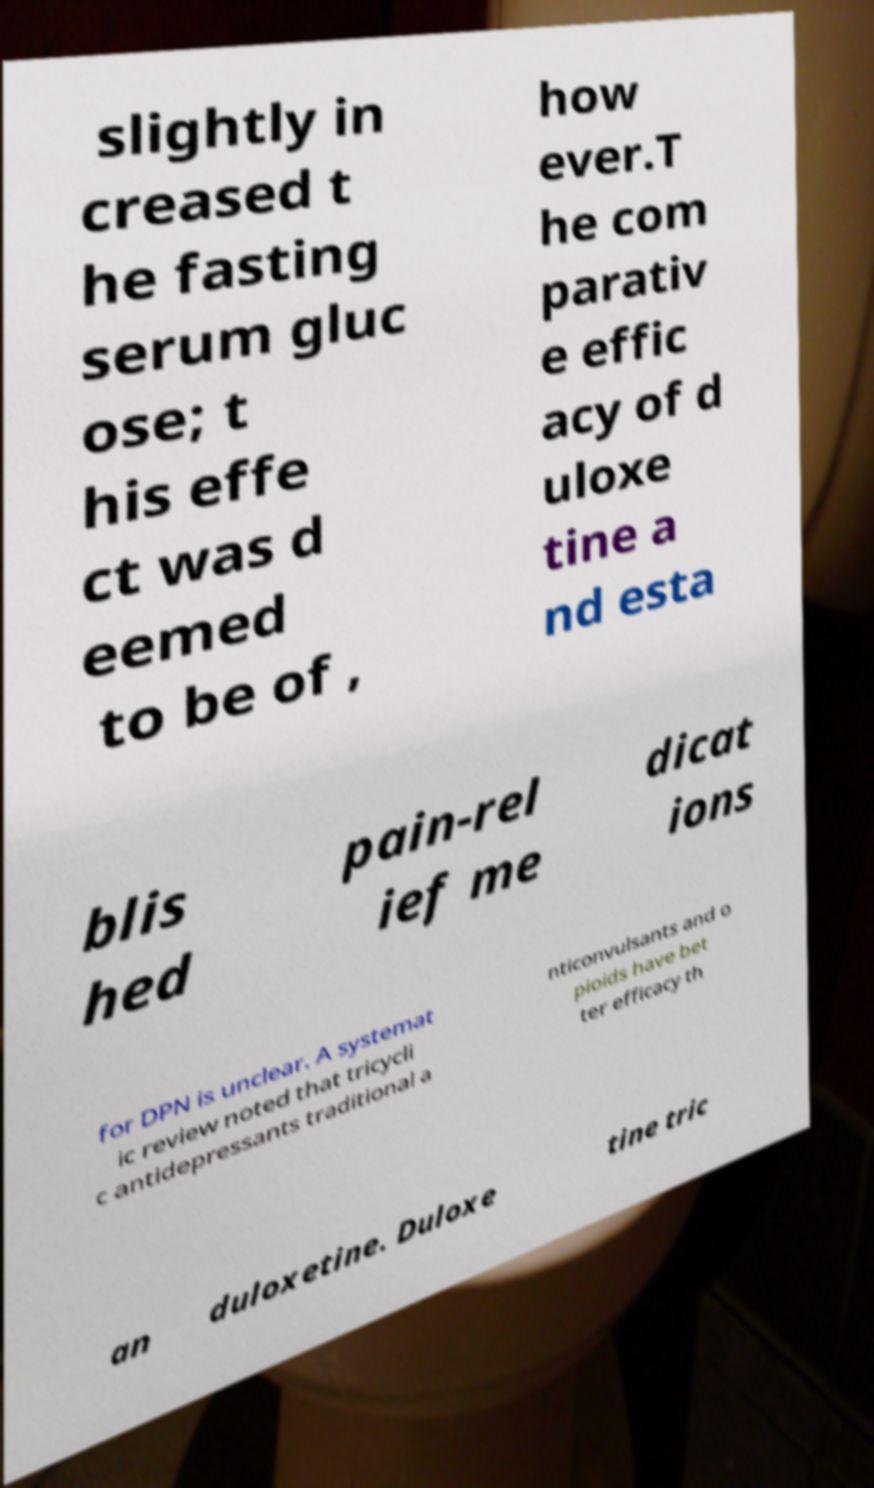Could you assist in decoding the text presented in this image and type it out clearly? slightly in creased t he fasting serum gluc ose; t his effe ct was d eemed to be of , how ever.T he com parativ e effic acy of d uloxe tine a nd esta blis hed pain-rel ief me dicat ions for DPN is unclear. A systemat ic review noted that tricycli c antidepressants traditional a nticonvulsants and o pioids have bet ter efficacy th an duloxetine. Duloxe tine tric 